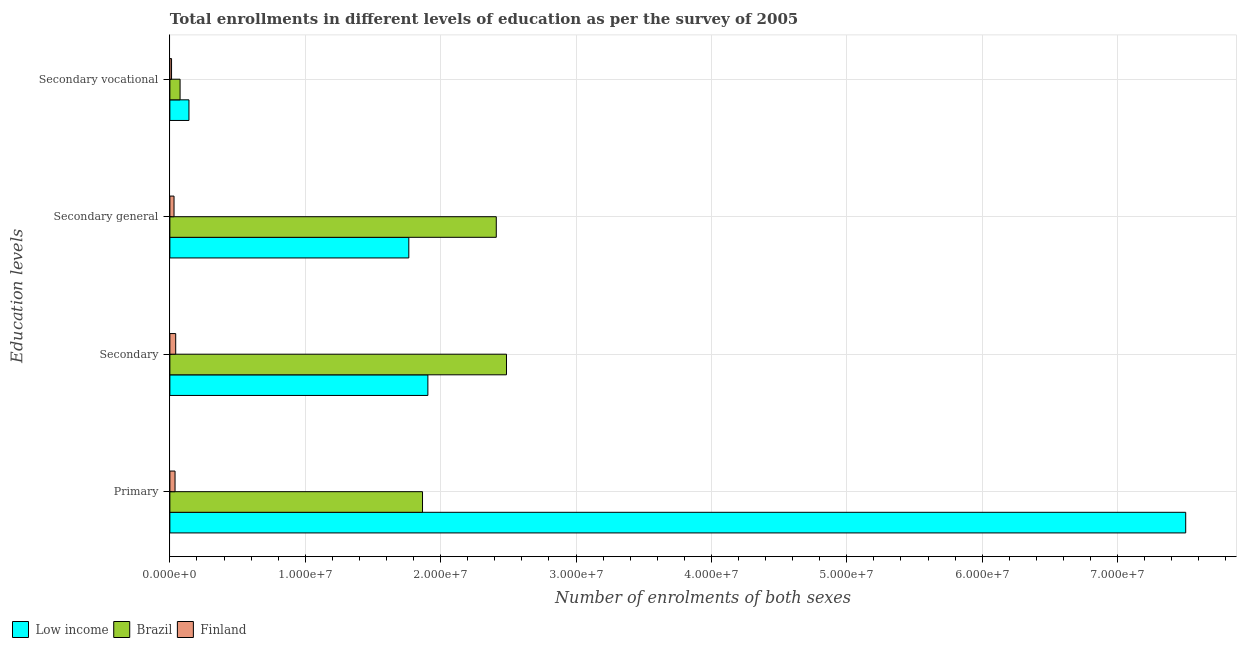How many different coloured bars are there?
Provide a succinct answer. 3. Are the number of bars on each tick of the Y-axis equal?
Provide a succinct answer. Yes. How many bars are there on the 3rd tick from the top?
Give a very brief answer. 3. How many bars are there on the 3rd tick from the bottom?
Ensure brevity in your answer.  3. What is the label of the 2nd group of bars from the top?
Give a very brief answer. Secondary general. What is the number of enrolments in secondary general education in Brazil?
Provide a succinct answer. 2.41e+07. Across all countries, what is the maximum number of enrolments in secondary general education?
Your response must be concise. 2.41e+07. Across all countries, what is the minimum number of enrolments in secondary education?
Provide a short and direct response. 4.31e+05. In which country was the number of enrolments in secondary education maximum?
Your response must be concise. Brazil. What is the total number of enrolments in secondary education in the graph?
Your answer should be very brief. 4.44e+07. What is the difference between the number of enrolments in secondary education in Low income and that in Finland?
Give a very brief answer. 1.86e+07. What is the difference between the number of enrolments in secondary education in Low income and the number of enrolments in secondary general education in Finland?
Ensure brevity in your answer.  1.87e+07. What is the average number of enrolments in secondary general education per country?
Provide a short and direct response. 1.40e+07. What is the difference between the number of enrolments in secondary vocational education and number of enrolments in secondary general education in Finland?
Your answer should be compact. -1.84e+05. In how many countries, is the number of enrolments in secondary general education greater than 66000000 ?
Your answer should be very brief. 0. What is the ratio of the number of enrolments in secondary general education in Finland to that in Brazil?
Offer a very short reply. 0.01. Is the number of enrolments in secondary general education in Brazil less than that in Finland?
Provide a short and direct response. No. What is the difference between the highest and the second highest number of enrolments in secondary vocational education?
Provide a short and direct response. 6.55e+05. What is the difference between the highest and the lowest number of enrolments in secondary general education?
Your answer should be very brief. 2.38e+07. In how many countries, is the number of enrolments in primary education greater than the average number of enrolments in primary education taken over all countries?
Ensure brevity in your answer.  1. Is the sum of the number of enrolments in secondary vocational education in Finland and Brazil greater than the maximum number of enrolments in primary education across all countries?
Make the answer very short. No. What does the 2nd bar from the top in Secondary general represents?
Offer a very short reply. Brazil. What does the 3rd bar from the bottom in Primary represents?
Your answer should be very brief. Finland. Are all the bars in the graph horizontal?
Ensure brevity in your answer.  Yes. How many countries are there in the graph?
Provide a succinct answer. 3. How many legend labels are there?
Offer a terse response. 3. How are the legend labels stacked?
Make the answer very short. Horizontal. What is the title of the graph?
Your answer should be compact. Total enrollments in different levels of education as per the survey of 2005. What is the label or title of the X-axis?
Your answer should be very brief. Number of enrolments of both sexes. What is the label or title of the Y-axis?
Offer a very short reply. Education levels. What is the Number of enrolments of both sexes of Low income in Primary?
Your answer should be compact. 7.50e+07. What is the Number of enrolments of both sexes of Brazil in Primary?
Offer a terse response. 1.87e+07. What is the Number of enrolments of both sexes in Finland in Primary?
Provide a short and direct response. 3.82e+05. What is the Number of enrolments of both sexes of Low income in Secondary?
Provide a short and direct response. 1.91e+07. What is the Number of enrolments of both sexes of Brazil in Secondary?
Make the answer very short. 2.49e+07. What is the Number of enrolments of both sexes in Finland in Secondary?
Your answer should be very brief. 4.31e+05. What is the Number of enrolments of both sexes of Low income in Secondary general?
Make the answer very short. 1.76e+07. What is the Number of enrolments of both sexes of Brazil in Secondary general?
Ensure brevity in your answer.  2.41e+07. What is the Number of enrolments of both sexes in Finland in Secondary general?
Your answer should be very brief. 3.07e+05. What is the Number of enrolments of both sexes in Low income in Secondary vocational?
Provide a short and direct response. 1.41e+06. What is the Number of enrolments of both sexes in Brazil in Secondary vocational?
Give a very brief answer. 7.54e+05. What is the Number of enrolments of both sexes of Finland in Secondary vocational?
Your response must be concise. 1.23e+05. Across all Education levels, what is the maximum Number of enrolments of both sexes in Low income?
Your answer should be compact. 7.50e+07. Across all Education levels, what is the maximum Number of enrolments of both sexes in Brazil?
Make the answer very short. 2.49e+07. Across all Education levels, what is the maximum Number of enrolments of both sexes of Finland?
Offer a terse response. 4.31e+05. Across all Education levels, what is the minimum Number of enrolments of both sexes of Low income?
Keep it short and to the point. 1.41e+06. Across all Education levels, what is the minimum Number of enrolments of both sexes of Brazil?
Your answer should be very brief. 7.54e+05. Across all Education levels, what is the minimum Number of enrolments of both sexes in Finland?
Offer a terse response. 1.23e+05. What is the total Number of enrolments of both sexes in Low income in the graph?
Your answer should be very brief. 1.13e+08. What is the total Number of enrolments of both sexes of Brazil in the graph?
Keep it short and to the point. 6.84e+07. What is the total Number of enrolments of both sexes of Finland in the graph?
Offer a terse response. 1.24e+06. What is the difference between the Number of enrolments of both sexes in Low income in Primary and that in Secondary?
Your answer should be compact. 5.60e+07. What is the difference between the Number of enrolments of both sexes in Brazil in Primary and that in Secondary?
Your response must be concise. -6.20e+06. What is the difference between the Number of enrolments of both sexes in Finland in Primary and that in Secondary?
Your answer should be very brief. -4.88e+04. What is the difference between the Number of enrolments of both sexes in Low income in Primary and that in Secondary general?
Keep it short and to the point. 5.74e+07. What is the difference between the Number of enrolments of both sexes of Brazil in Primary and that in Secondary general?
Give a very brief answer. -5.45e+06. What is the difference between the Number of enrolments of both sexes in Finland in Primary and that in Secondary general?
Offer a terse response. 7.43e+04. What is the difference between the Number of enrolments of both sexes of Low income in Primary and that in Secondary vocational?
Your answer should be very brief. 7.36e+07. What is the difference between the Number of enrolments of both sexes in Brazil in Primary and that in Secondary vocational?
Keep it short and to the point. 1.79e+07. What is the difference between the Number of enrolments of both sexes in Finland in Primary and that in Secondary vocational?
Make the answer very short. 2.59e+05. What is the difference between the Number of enrolments of both sexes of Low income in Secondary and that in Secondary general?
Provide a short and direct response. 1.41e+06. What is the difference between the Number of enrolments of both sexes of Brazil in Secondary and that in Secondary general?
Keep it short and to the point. 7.54e+05. What is the difference between the Number of enrolments of both sexes of Finland in Secondary and that in Secondary general?
Ensure brevity in your answer.  1.23e+05. What is the difference between the Number of enrolments of both sexes of Low income in Secondary and that in Secondary vocational?
Make the answer very short. 1.76e+07. What is the difference between the Number of enrolments of both sexes of Brazil in Secondary and that in Secondary vocational?
Your response must be concise. 2.41e+07. What is the difference between the Number of enrolments of both sexes of Finland in Secondary and that in Secondary vocational?
Offer a very short reply. 3.07e+05. What is the difference between the Number of enrolments of both sexes in Low income in Secondary general and that in Secondary vocational?
Your response must be concise. 1.62e+07. What is the difference between the Number of enrolments of both sexes in Brazil in Secondary general and that in Secondary vocational?
Your answer should be compact. 2.34e+07. What is the difference between the Number of enrolments of both sexes of Finland in Secondary general and that in Secondary vocational?
Offer a terse response. 1.84e+05. What is the difference between the Number of enrolments of both sexes in Low income in Primary and the Number of enrolments of both sexes in Brazil in Secondary?
Ensure brevity in your answer.  5.02e+07. What is the difference between the Number of enrolments of both sexes in Low income in Primary and the Number of enrolments of both sexes in Finland in Secondary?
Keep it short and to the point. 7.46e+07. What is the difference between the Number of enrolments of both sexes in Brazil in Primary and the Number of enrolments of both sexes in Finland in Secondary?
Your answer should be very brief. 1.82e+07. What is the difference between the Number of enrolments of both sexes in Low income in Primary and the Number of enrolments of both sexes in Brazil in Secondary general?
Your answer should be very brief. 5.09e+07. What is the difference between the Number of enrolments of both sexes in Low income in Primary and the Number of enrolments of both sexes in Finland in Secondary general?
Keep it short and to the point. 7.47e+07. What is the difference between the Number of enrolments of both sexes of Brazil in Primary and the Number of enrolments of both sexes of Finland in Secondary general?
Provide a succinct answer. 1.84e+07. What is the difference between the Number of enrolments of both sexes in Low income in Primary and the Number of enrolments of both sexes in Brazil in Secondary vocational?
Provide a succinct answer. 7.43e+07. What is the difference between the Number of enrolments of both sexes of Low income in Primary and the Number of enrolments of both sexes of Finland in Secondary vocational?
Ensure brevity in your answer.  7.49e+07. What is the difference between the Number of enrolments of both sexes in Brazil in Primary and the Number of enrolments of both sexes in Finland in Secondary vocational?
Ensure brevity in your answer.  1.85e+07. What is the difference between the Number of enrolments of both sexes of Low income in Secondary and the Number of enrolments of both sexes of Brazil in Secondary general?
Offer a very short reply. -5.05e+06. What is the difference between the Number of enrolments of both sexes in Low income in Secondary and the Number of enrolments of both sexes in Finland in Secondary general?
Your response must be concise. 1.87e+07. What is the difference between the Number of enrolments of both sexes of Brazil in Secondary and the Number of enrolments of both sexes of Finland in Secondary general?
Give a very brief answer. 2.46e+07. What is the difference between the Number of enrolments of both sexes of Low income in Secondary and the Number of enrolments of both sexes of Brazil in Secondary vocational?
Offer a very short reply. 1.83e+07. What is the difference between the Number of enrolments of both sexes of Low income in Secondary and the Number of enrolments of both sexes of Finland in Secondary vocational?
Offer a terse response. 1.89e+07. What is the difference between the Number of enrolments of both sexes in Brazil in Secondary and the Number of enrolments of both sexes in Finland in Secondary vocational?
Your response must be concise. 2.47e+07. What is the difference between the Number of enrolments of both sexes in Low income in Secondary general and the Number of enrolments of both sexes in Brazil in Secondary vocational?
Your answer should be very brief. 1.69e+07. What is the difference between the Number of enrolments of both sexes of Low income in Secondary general and the Number of enrolments of both sexes of Finland in Secondary vocational?
Provide a succinct answer. 1.75e+07. What is the difference between the Number of enrolments of both sexes of Brazil in Secondary general and the Number of enrolments of both sexes of Finland in Secondary vocational?
Offer a very short reply. 2.40e+07. What is the average Number of enrolments of both sexes in Low income per Education levels?
Provide a succinct answer. 2.83e+07. What is the average Number of enrolments of both sexes of Brazil per Education levels?
Provide a short and direct response. 1.71e+07. What is the average Number of enrolments of both sexes in Finland per Education levels?
Provide a short and direct response. 3.11e+05. What is the difference between the Number of enrolments of both sexes in Low income and Number of enrolments of both sexes in Brazil in Primary?
Ensure brevity in your answer.  5.64e+07. What is the difference between the Number of enrolments of both sexes of Low income and Number of enrolments of both sexes of Finland in Primary?
Make the answer very short. 7.46e+07. What is the difference between the Number of enrolments of both sexes of Brazil and Number of enrolments of both sexes of Finland in Primary?
Keep it short and to the point. 1.83e+07. What is the difference between the Number of enrolments of both sexes in Low income and Number of enrolments of both sexes in Brazil in Secondary?
Ensure brevity in your answer.  -5.81e+06. What is the difference between the Number of enrolments of both sexes of Low income and Number of enrolments of both sexes of Finland in Secondary?
Your answer should be very brief. 1.86e+07. What is the difference between the Number of enrolments of both sexes in Brazil and Number of enrolments of both sexes in Finland in Secondary?
Your answer should be compact. 2.44e+07. What is the difference between the Number of enrolments of both sexes of Low income and Number of enrolments of both sexes of Brazil in Secondary general?
Your response must be concise. -6.46e+06. What is the difference between the Number of enrolments of both sexes in Low income and Number of enrolments of both sexes in Finland in Secondary general?
Offer a terse response. 1.73e+07. What is the difference between the Number of enrolments of both sexes in Brazil and Number of enrolments of both sexes in Finland in Secondary general?
Your answer should be compact. 2.38e+07. What is the difference between the Number of enrolments of both sexes of Low income and Number of enrolments of both sexes of Brazil in Secondary vocational?
Provide a succinct answer. 6.55e+05. What is the difference between the Number of enrolments of both sexes of Low income and Number of enrolments of both sexes of Finland in Secondary vocational?
Your response must be concise. 1.29e+06. What is the difference between the Number of enrolments of both sexes of Brazil and Number of enrolments of both sexes of Finland in Secondary vocational?
Provide a succinct answer. 6.30e+05. What is the ratio of the Number of enrolments of both sexes of Low income in Primary to that in Secondary?
Your answer should be compact. 3.94. What is the ratio of the Number of enrolments of both sexes in Brazil in Primary to that in Secondary?
Ensure brevity in your answer.  0.75. What is the ratio of the Number of enrolments of both sexes in Finland in Primary to that in Secondary?
Your answer should be compact. 0.89. What is the ratio of the Number of enrolments of both sexes in Low income in Primary to that in Secondary general?
Provide a short and direct response. 4.25. What is the ratio of the Number of enrolments of both sexes of Brazil in Primary to that in Secondary general?
Make the answer very short. 0.77. What is the ratio of the Number of enrolments of both sexes of Finland in Primary to that in Secondary general?
Keep it short and to the point. 1.24. What is the ratio of the Number of enrolments of both sexes of Low income in Primary to that in Secondary vocational?
Your response must be concise. 53.25. What is the ratio of the Number of enrolments of both sexes of Brazil in Primary to that in Secondary vocational?
Make the answer very short. 24.77. What is the ratio of the Number of enrolments of both sexes of Finland in Primary to that in Secondary vocational?
Offer a terse response. 3.1. What is the ratio of the Number of enrolments of both sexes in Low income in Secondary to that in Secondary general?
Your response must be concise. 1.08. What is the ratio of the Number of enrolments of both sexes of Brazil in Secondary to that in Secondary general?
Give a very brief answer. 1.03. What is the ratio of the Number of enrolments of both sexes in Finland in Secondary to that in Secondary general?
Ensure brevity in your answer.  1.4. What is the ratio of the Number of enrolments of both sexes of Low income in Secondary to that in Secondary vocational?
Offer a very short reply. 13.53. What is the ratio of the Number of enrolments of both sexes in Brazil in Secondary to that in Secondary vocational?
Your answer should be very brief. 33. What is the ratio of the Number of enrolments of both sexes of Finland in Secondary to that in Secondary vocational?
Give a very brief answer. 3.5. What is the ratio of the Number of enrolments of both sexes in Low income in Secondary general to that in Secondary vocational?
Provide a short and direct response. 12.53. What is the ratio of the Number of enrolments of both sexes of Brazil in Secondary general to that in Secondary vocational?
Provide a short and direct response. 32. What is the ratio of the Number of enrolments of both sexes of Finland in Secondary general to that in Secondary vocational?
Keep it short and to the point. 2.5. What is the difference between the highest and the second highest Number of enrolments of both sexes of Low income?
Keep it short and to the point. 5.60e+07. What is the difference between the highest and the second highest Number of enrolments of both sexes of Brazil?
Your response must be concise. 7.54e+05. What is the difference between the highest and the second highest Number of enrolments of both sexes of Finland?
Offer a terse response. 4.88e+04. What is the difference between the highest and the lowest Number of enrolments of both sexes in Low income?
Keep it short and to the point. 7.36e+07. What is the difference between the highest and the lowest Number of enrolments of both sexes of Brazil?
Ensure brevity in your answer.  2.41e+07. What is the difference between the highest and the lowest Number of enrolments of both sexes of Finland?
Make the answer very short. 3.07e+05. 